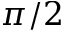Convert formula to latex. <formula><loc_0><loc_0><loc_500><loc_500>\pi / 2</formula> 